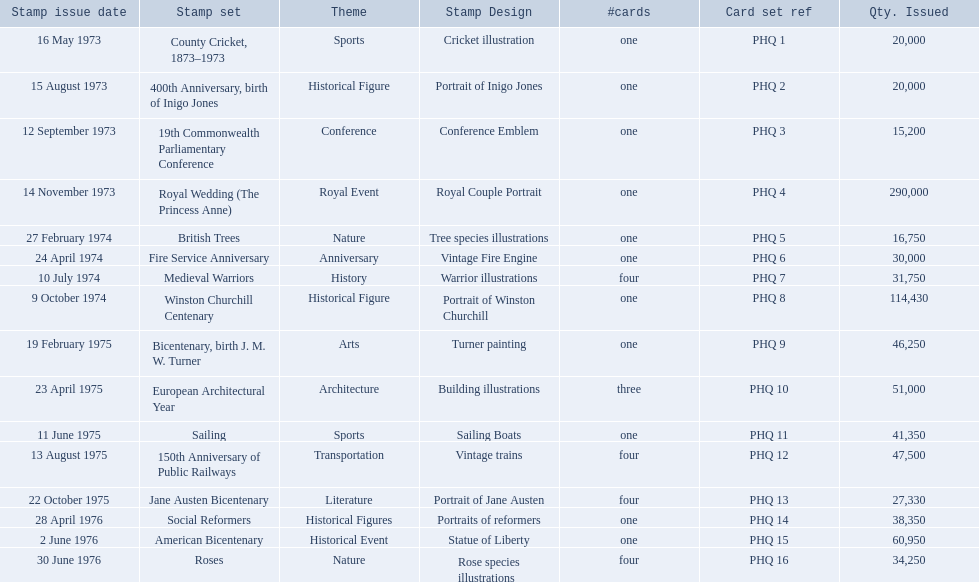What are all the stamp sets? County Cricket, 1873–1973, 400th Anniversary, birth of Inigo Jones, 19th Commonwealth Parliamentary Conference, Royal Wedding (The Princess Anne), British Trees, Fire Service Anniversary, Medieval Warriors, Winston Churchill Centenary, Bicentenary, birth J. M. W. Turner, European Architectural Year, Sailing, 150th Anniversary of Public Railways, Jane Austen Bicentenary, Social Reformers, American Bicentenary, Roses. For these sets, what were the quantities issued? 20,000, 20,000, 15,200, 290,000, 16,750, 30,000, 31,750, 114,430, 46,250, 51,000, 41,350, 47,500, 27,330, 38,350, 60,950, 34,250. Of these, which quantity is above 200,000? 290,000. What is the stamp set corresponding to this quantity? Royal Wedding (The Princess Anne). 